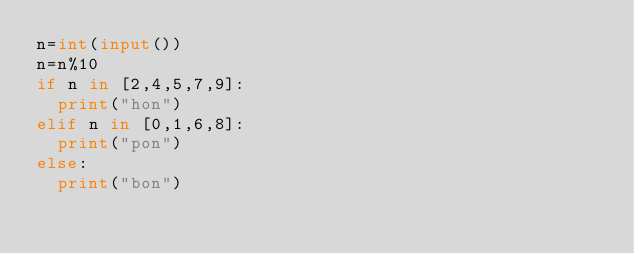Convert code to text. <code><loc_0><loc_0><loc_500><loc_500><_Python_>n=int(input())
n=n%10
if n in [2,4,5,7,9]:
  print("hon")
elif n in [0,1,6,8]:
  print("pon")
else:
  print("bon")</code> 